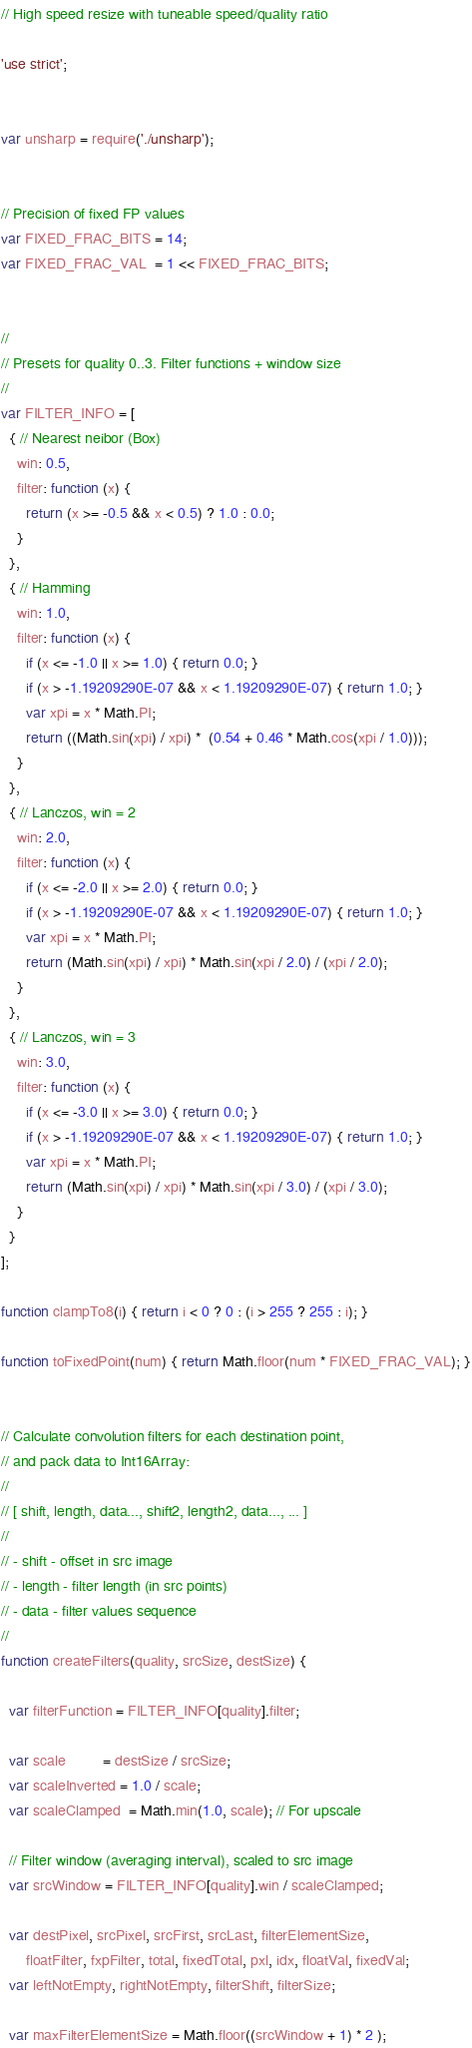<code> <loc_0><loc_0><loc_500><loc_500><_JavaScript_>// High speed resize with tuneable speed/quality ratio

'use strict';


var unsharp = require('./unsharp');


// Precision of fixed FP values
var FIXED_FRAC_BITS = 14;
var FIXED_FRAC_VAL  = 1 << FIXED_FRAC_BITS;


//
// Presets for quality 0..3. Filter functions + window size
//
var FILTER_INFO = [
  { // Nearest neibor (Box)
    win: 0.5,
    filter: function (x) {
      return (x >= -0.5 && x < 0.5) ? 1.0 : 0.0;
    }
  },
  { // Hamming
    win: 1.0,
    filter: function (x) {
      if (x <= -1.0 || x >= 1.0) { return 0.0; }
      if (x > -1.19209290E-07 && x < 1.19209290E-07) { return 1.0; }
      var xpi = x * Math.PI;
      return ((Math.sin(xpi) / xpi) *  (0.54 + 0.46 * Math.cos(xpi / 1.0)));
    }
  },
  { // Lanczos, win = 2
    win: 2.0,
    filter: function (x) {
      if (x <= -2.0 || x >= 2.0) { return 0.0; }
      if (x > -1.19209290E-07 && x < 1.19209290E-07) { return 1.0; }
      var xpi = x * Math.PI;
      return (Math.sin(xpi) / xpi) * Math.sin(xpi / 2.0) / (xpi / 2.0);
    }
  },
  { // Lanczos, win = 3
    win: 3.0,
    filter: function (x) {
      if (x <= -3.0 || x >= 3.0) { return 0.0; }
      if (x > -1.19209290E-07 && x < 1.19209290E-07) { return 1.0; }
      var xpi = x * Math.PI;
      return (Math.sin(xpi) / xpi) * Math.sin(xpi / 3.0) / (xpi / 3.0);
    }
  }
];

function clampTo8(i) { return i < 0 ? 0 : (i > 255 ? 255 : i); }

function toFixedPoint(num) { return Math.floor(num * FIXED_FRAC_VAL); }


// Calculate convolution filters for each destination point,
// and pack data to Int16Array:
//
// [ shift, length, data..., shift2, length2, data..., ... ]
//
// - shift - offset in src image
// - length - filter length (in src points)
// - data - filter values sequence
//
function createFilters(quality, srcSize, destSize) {

  var filterFunction = FILTER_INFO[quality].filter;

  var scale         = destSize / srcSize;
  var scaleInverted = 1.0 / scale;
  var scaleClamped  = Math.min(1.0, scale); // For upscale

  // Filter window (averaging interval), scaled to src image
  var srcWindow = FILTER_INFO[quality].win / scaleClamped;

  var destPixel, srcPixel, srcFirst, srcLast, filterElementSize,
      floatFilter, fxpFilter, total, fixedTotal, pxl, idx, floatVal, fixedVal;
  var leftNotEmpty, rightNotEmpty, filterShift, filterSize;

  var maxFilterElementSize = Math.floor((srcWindow + 1) * 2 );</code> 